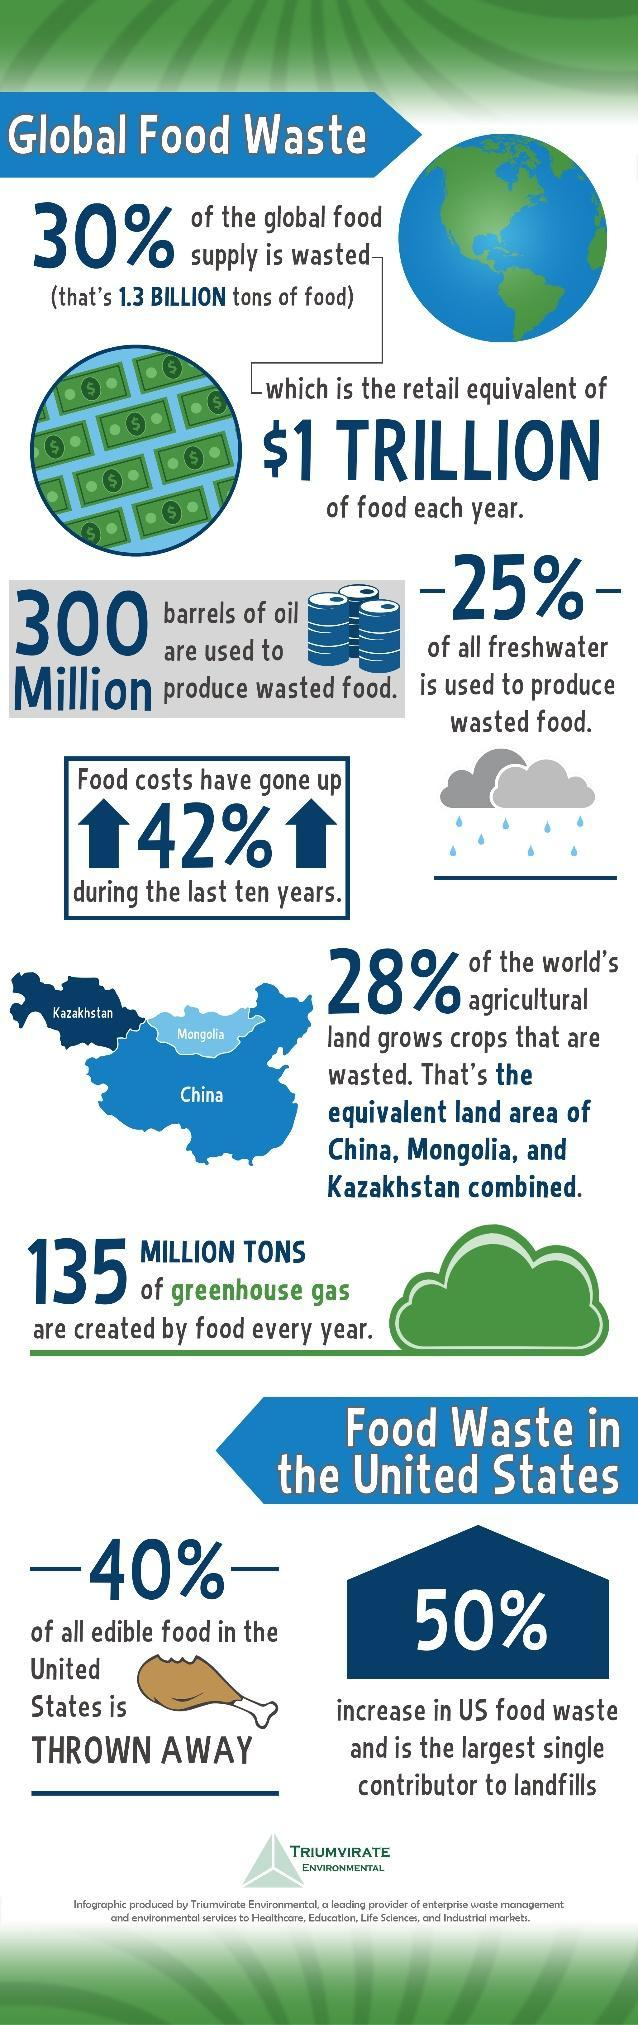The area agricultural land growing wasted crops is equivalent of how many countries?
Answer the question with a short phrase. 3 What is the percentage increase in US food waste, 40%, 50%, or 42% ? 50% 